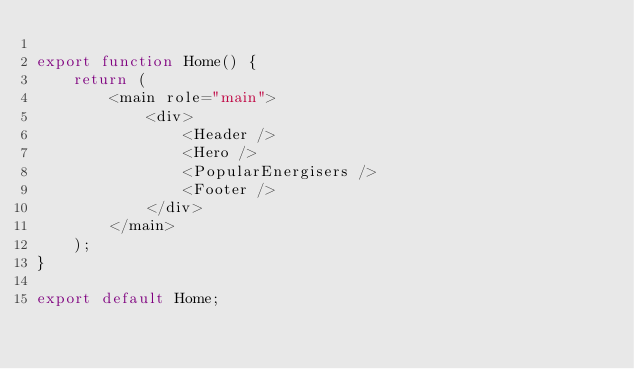Convert code to text. <code><loc_0><loc_0><loc_500><loc_500><_JavaScript_>
export function Home() {
	return (
		<main role="main">
			<div>
				<Header />
				<Hero />
				<PopularEnergisers />
				<Footer />
			</div>
		</main>
	);
}

export default Home;</code> 